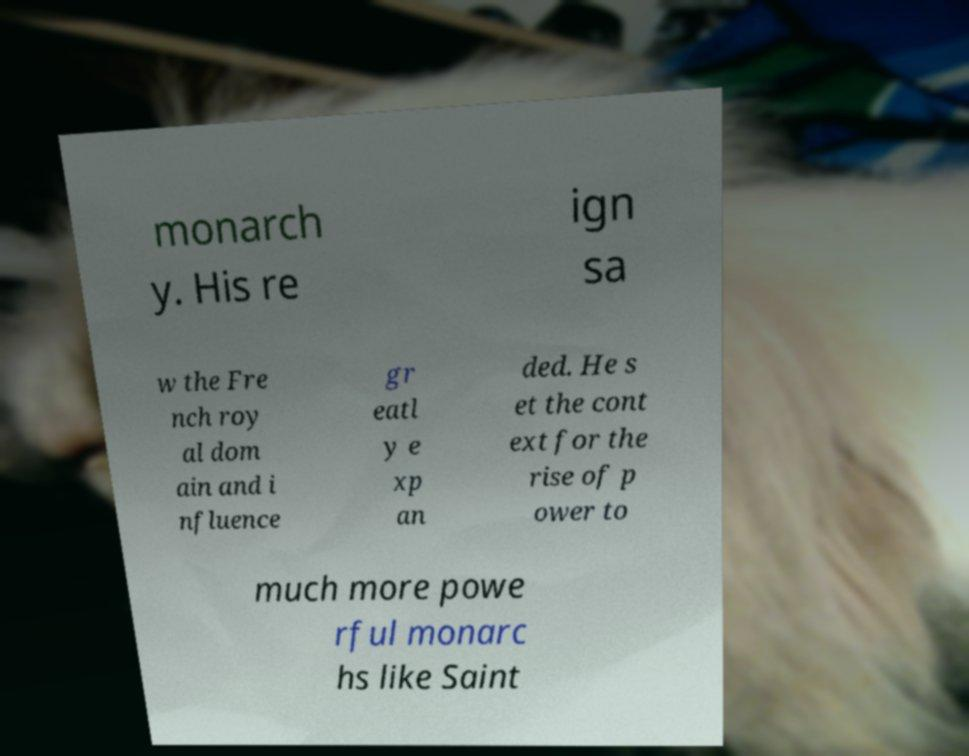For documentation purposes, I need the text within this image transcribed. Could you provide that? monarch y. His re ign sa w the Fre nch roy al dom ain and i nfluence gr eatl y e xp an ded. He s et the cont ext for the rise of p ower to much more powe rful monarc hs like Saint 